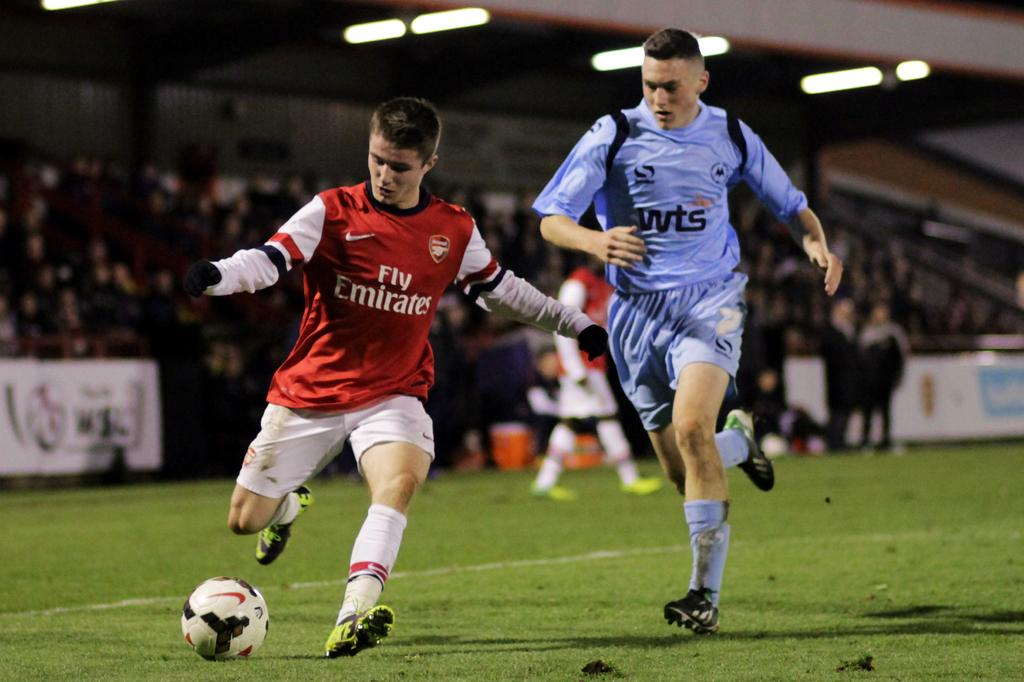How many people are in the image? There are two persons in the image. What are the persons doing in the image? The persons are running on the ground. What object is on the ground in the image? There is a ball on the ground. How many dolls are present in the image? There are no dolls present in the image. What type of roll can be seen in the image? There is no roll visible in the image. 